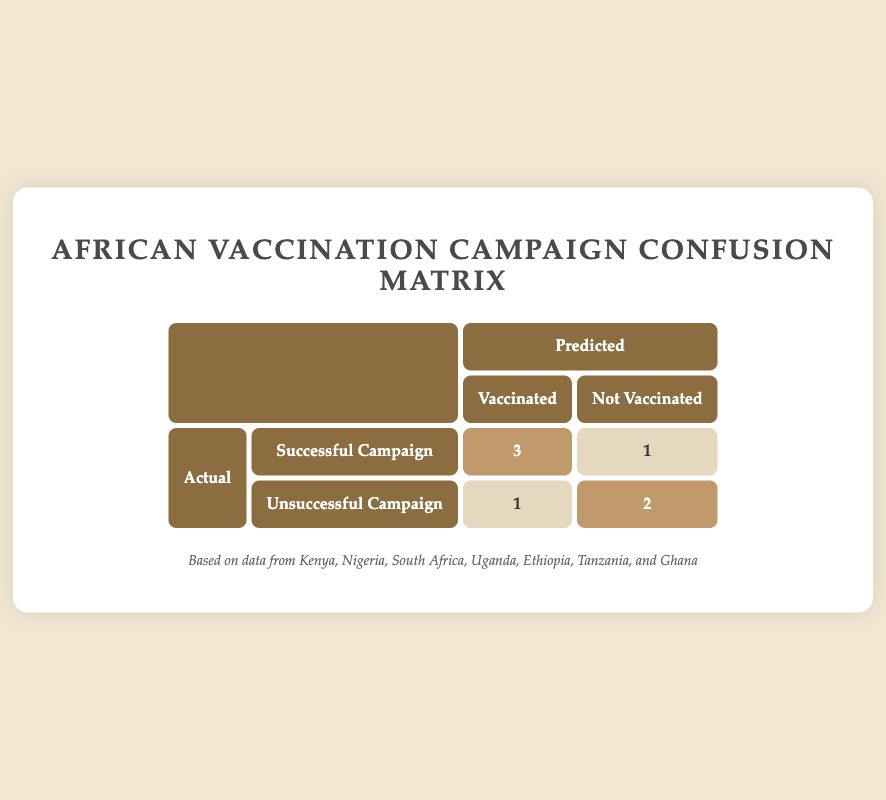What's the total number of successful campaigns that led to vaccinations? From the table, we see that there are 3 successful campaigns where the vaccination status is "vaccinated" (Kenya, Nigeria, and Tanzania). Adding these up gives us a total of 3.
Answer: 3 How many unsuccessful campaigns resulted in non-vaccination? There are 2 unsuccessful campaigns that resulted in "not vaccinated" status (South Africa and Ghana), so the total is 2.
Answer: 2 Is it true that all successful campaigns resulted in vaccinations? Looking at the table, there is one successful campaign (Uganda) that resulted in "not vaccinated", which means not all successful campaigns led to vaccinations.
Answer: No What is the ratio of successful campaigns that led to vaccinations compared to total successful campaigns? There are 3 successful campaigns that resulted in vaccinations and 4 total successful campaigns (3 vaccinated + 1 not vaccinated). The ratio is 3:4 or 75%.
Answer: 3:4 How many total campaigns were assessed in this data? From the data, we can see there are 7 countries listed, each representing a campaign, meaning a total of 7 campaigns were assessed.
Answer: 7 Which country had a successful campaign but did not vaccinate its population? The country that had a successful campaign but resulted in "not vaccinated" is Uganda, as indicated in the table.
Answer: Uganda What percentage of vaccinated individuals came from successful campaigns? There are 3 individuals from successful campaigns that are vaccinated and 3 total who are vaccinated (Kenya, Nigeria, and Ethiopia). Therefore, the percentage of vaccinated individuals from successful campaigns is (3/3) * 100 = 100%.
Answer: 100% What is the count of campaigns categorized as unsuccessful? In the table, there are 3 campaigns categorized as unsuccessful (South Africa, Ethiopia, and Ghana) based on the data provided.
Answer: 3 